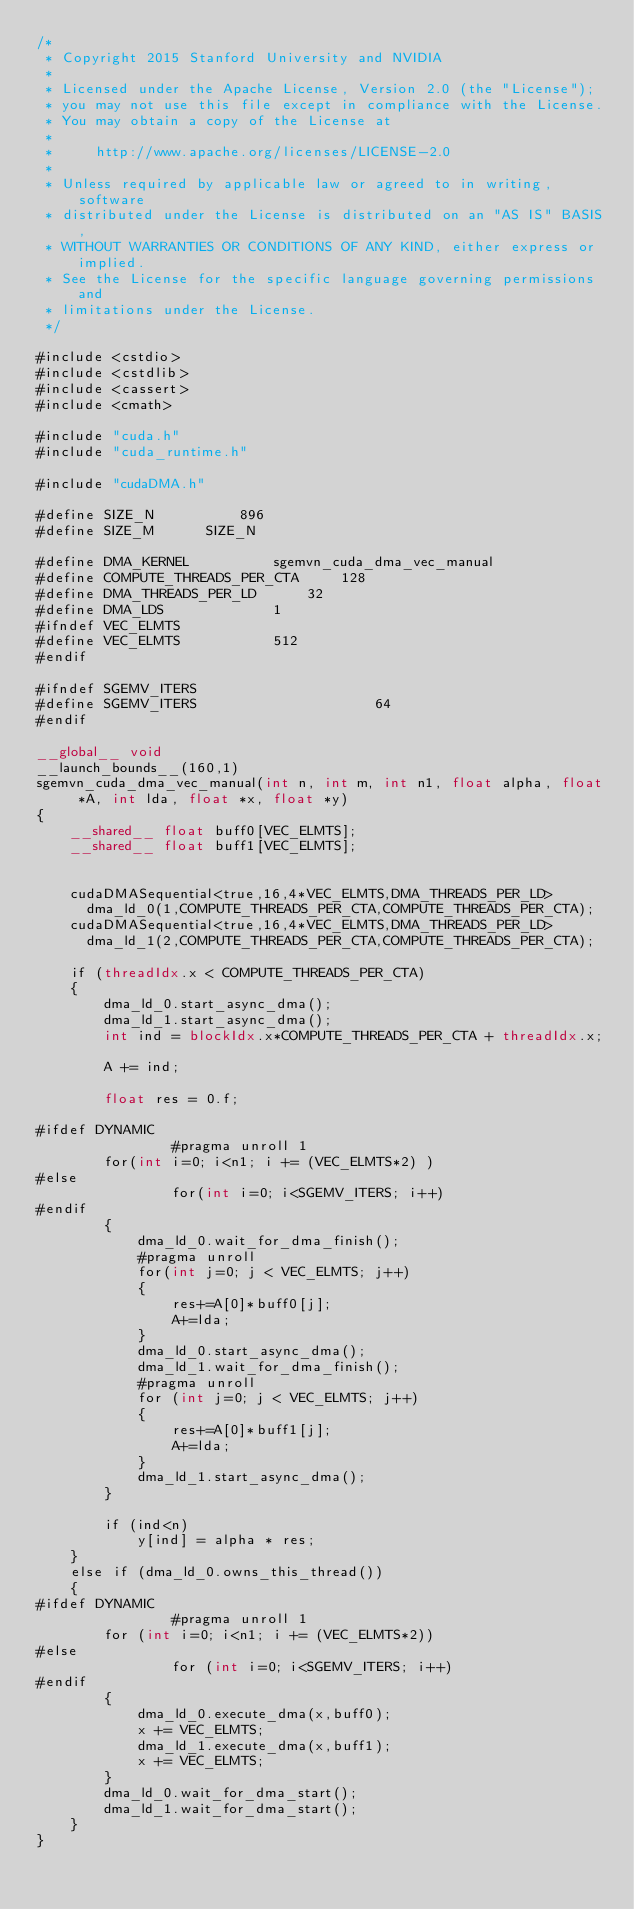<code> <loc_0><loc_0><loc_500><loc_500><_Cuda_>/*
 * Copyright 2015 Stanford University and NVIDIA
 *
 * Licensed under the Apache License, Version 2.0 (the "License");
 * you may not use this file except in compliance with the License.
 * You may obtain a copy of the License at
 *
 *     http://www.apache.org/licenses/LICENSE-2.0
 *
 * Unless required by applicable law or agreed to in writing, software
 * distributed under the License is distributed on an "AS IS" BASIS,
 * WITHOUT WARRANTIES OR CONDITIONS OF ANY KIND, either express or implied.
 * See the License for the specific language governing permissions and
 * limitations under the License.
 */

#include <cstdio>
#include <cstdlib>
#include <cassert>
#include <cmath>

#include "cuda.h"
#include "cuda_runtime.h"

#include "cudaDMA.h"

#define SIZE_N	        896
#define SIZE_M		SIZE_N

#define DMA_KERNEL			sgemvn_cuda_dma_vec_manual
#define COMPUTE_THREADS_PER_CTA		128	
#define DMA_THREADS_PER_LD		32
#define DMA_LDS				1
#ifndef VEC_ELMTS
#define VEC_ELMTS			512	
#endif

#ifndef SGEMV_ITERS
#define SGEMV_ITERS                     64
#endif

__global__ void
__launch_bounds__(160,1)
sgemvn_cuda_dma_vec_manual(int n, int m, int n1, float alpha, float *A, int lda, float *x, float *y)
{
	__shared__ float buff0[VEC_ELMTS];
	__shared__ float buff1[VEC_ELMTS];


	cudaDMASequential<true,16,4*VEC_ELMTS,DMA_THREADS_PER_LD>
	  dma_ld_0(1,COMPUTE_THREADS_PER_CTA,COMPUTE_THREADS_PER_CTA);
	cudaDMASequential<true,16,4*VEC_ELMTS,DMA_THREADS_PER_LD>
	  dma_ld_1(2,COMPUTE_THREADS_PER_CTA,COMPUTE_THREADS_PER_CTA);

	if (threadIdx.x < COMPUTE_THREADS_PER_CTA)
	{
		dma_ld_0.start_async_dma();	
		dma_ld_1.start_async_dma();
		int ind = blockIdx.x*COMPUTE_THREADS_PER_CTA + threadIdx.x;

		A += ind;

		float res = 0.f;

#ifdef DYNAMIC
                #pragma unroll 1
		for(int i=0; i<n1; i += (VEC_ELMTS*2) )
#else
                for(int i=0; i<SGEMV_ITERS; i++)
#endif
		{
			dma_ld_0.wait_for_dma_finish();
			#pragma unroll
			for(int j=0; j < VEC_ELMTS; j++)
			{
				res+=A[0]*buff0[j];
				A+=lda;
			}
			dma_ld_0.start_async_dma();
			dma_ld_1.wait_for_dma_finish();
			#pragma unroll
			for (int j=0; j < VEC_ELMTS; j++)
			{
				res+=A[0]*buff1[j];
				A+=lda;
			}
			dma_ld_1.start_async_dma();
		}

		if (ind<n)
			y[ind] = alpha * res;
	}
	else if (dma_ld_0.owns_this_thread())
	{
#ifdef DYNAMIC
                #pragma unroll 1
		for (int i=0; i<n1; i += (VEC_ELMTS*2))
#else
                for (int i=0; i<SGEMV_ITERS; i++)
#endif
		{
			dma_ld_0.execute_dma(x,buff0);
			x += VEC_ELMTS;
			dma_ld_1.execute_dma(x,buff1);
			x += VEC_ELMTS;
		}	
		dma_ld_0.wait_for_dma_start();
		dma_ld_1.wait_for_dma_start();
	}
}

</code> 